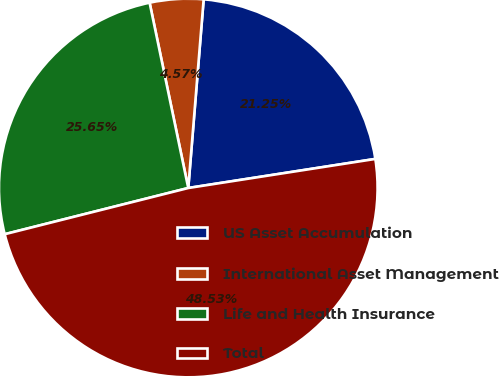Convert chart. <chart><loc_0><loc_0><loc_500><loc_500><pie_chart><fcel>US Asset Accumulation<fcel>International Asset Management<fcel>Life and Health Insurance<fcel>Total<nl><fcel>21.25%<fcel>4.57%<fcel>25.65%<fcel>48.53%<nl></chart> 